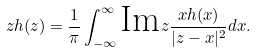<formula> <loc_0><loc_0><loc_500><loc_500>z h ( z ) = \frac { 1 } { \pi } \int _ { - \infty } ^ { \infty } \text {Im} z \frac { x h ( x ) } { | z - x | ^ { 2 } } d x .</formula> 